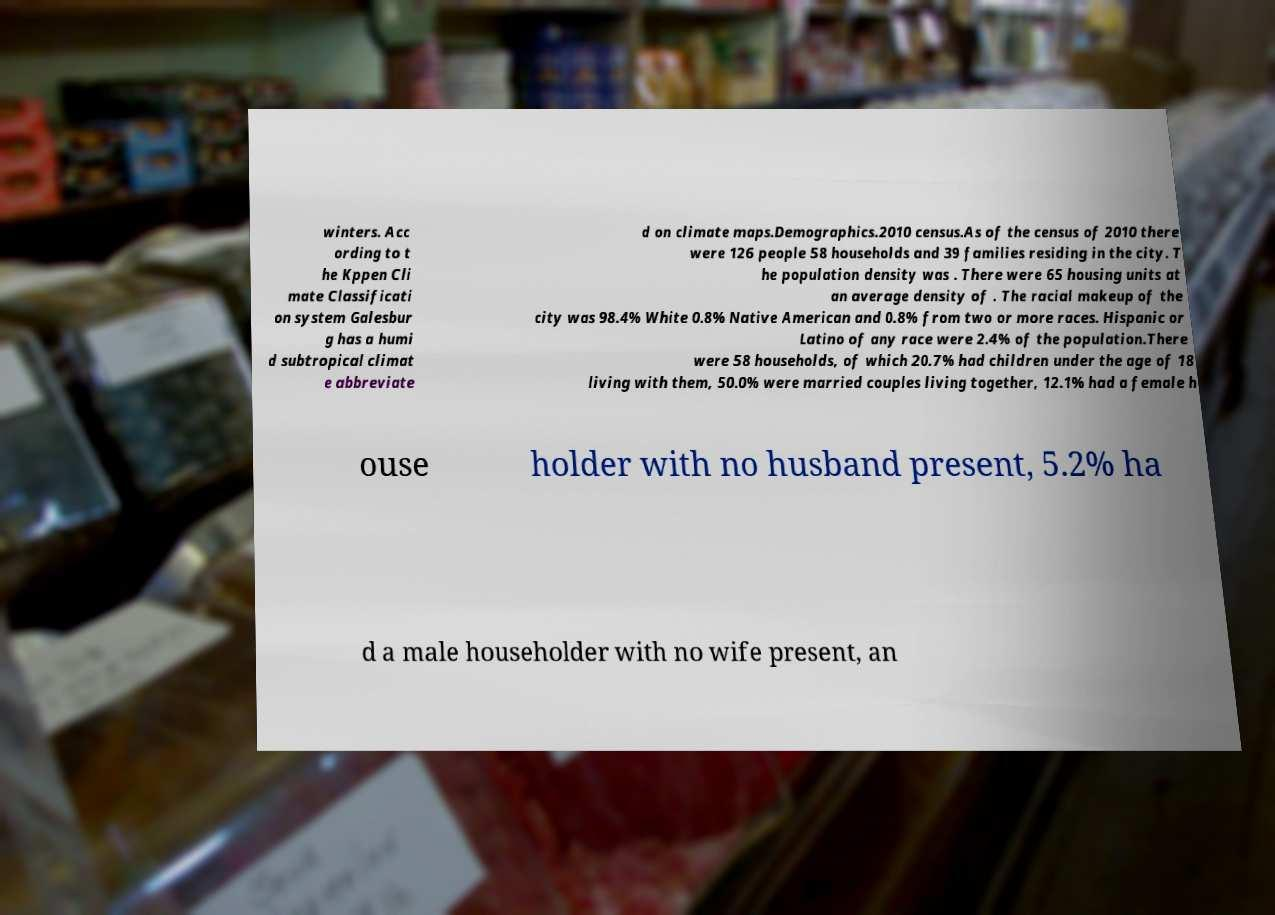Could you extract and type out the text from this image? winters. Acc ording to t he Kppen Cli mate Classificati on system Galesbur g has a humi d subtropical climat e abbreviate d on climate maps.Demographics.2010 census.As of the census of 2010 there were 126 people 58 households and 39 families residing in the city. T he population density was . There were 65 housing units at an average density of . The racial makeup of the city was 98.4% White 0.8% Native American and 0.8% from two or more races. Hispanic or Latino of any race were 2.4% of the population.There were 58 households, of which 20.7% had children under the age of 18 living with them, 50.0% were married couples living together, 12.1% had a female h ouse holder with no husband present, 5.2% ha d a male householder with no wife present, an 